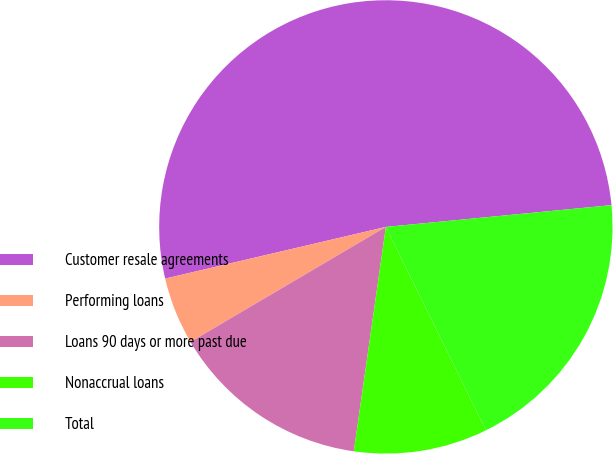<chart> <loc_0><loc_0><loc_500><loc_500><pie_chart><fcel>Customer resale agreements<fcel>Performing loans<fcel>Loans 90 days or more past due<fcel>Nonaccrual loans<fcel>Total<nl><fcel>52.13%<fcel>4.81%<fcel>14.27%<fcel>9.54%<fcel>19.25%<nl></chart> 